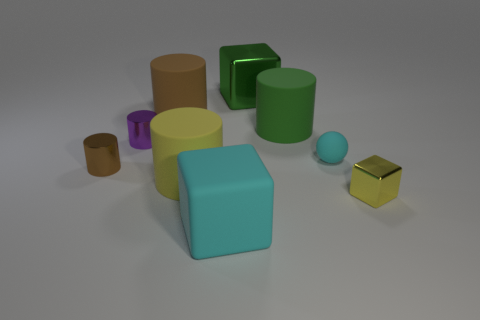If these objects were part of a child's toy set, what could be a potential educational purpose for them? These objects could be used for several educational purposes, such as teaching children about different geometric shapes, exploring size comparisons, and understanding color identification and matching. 